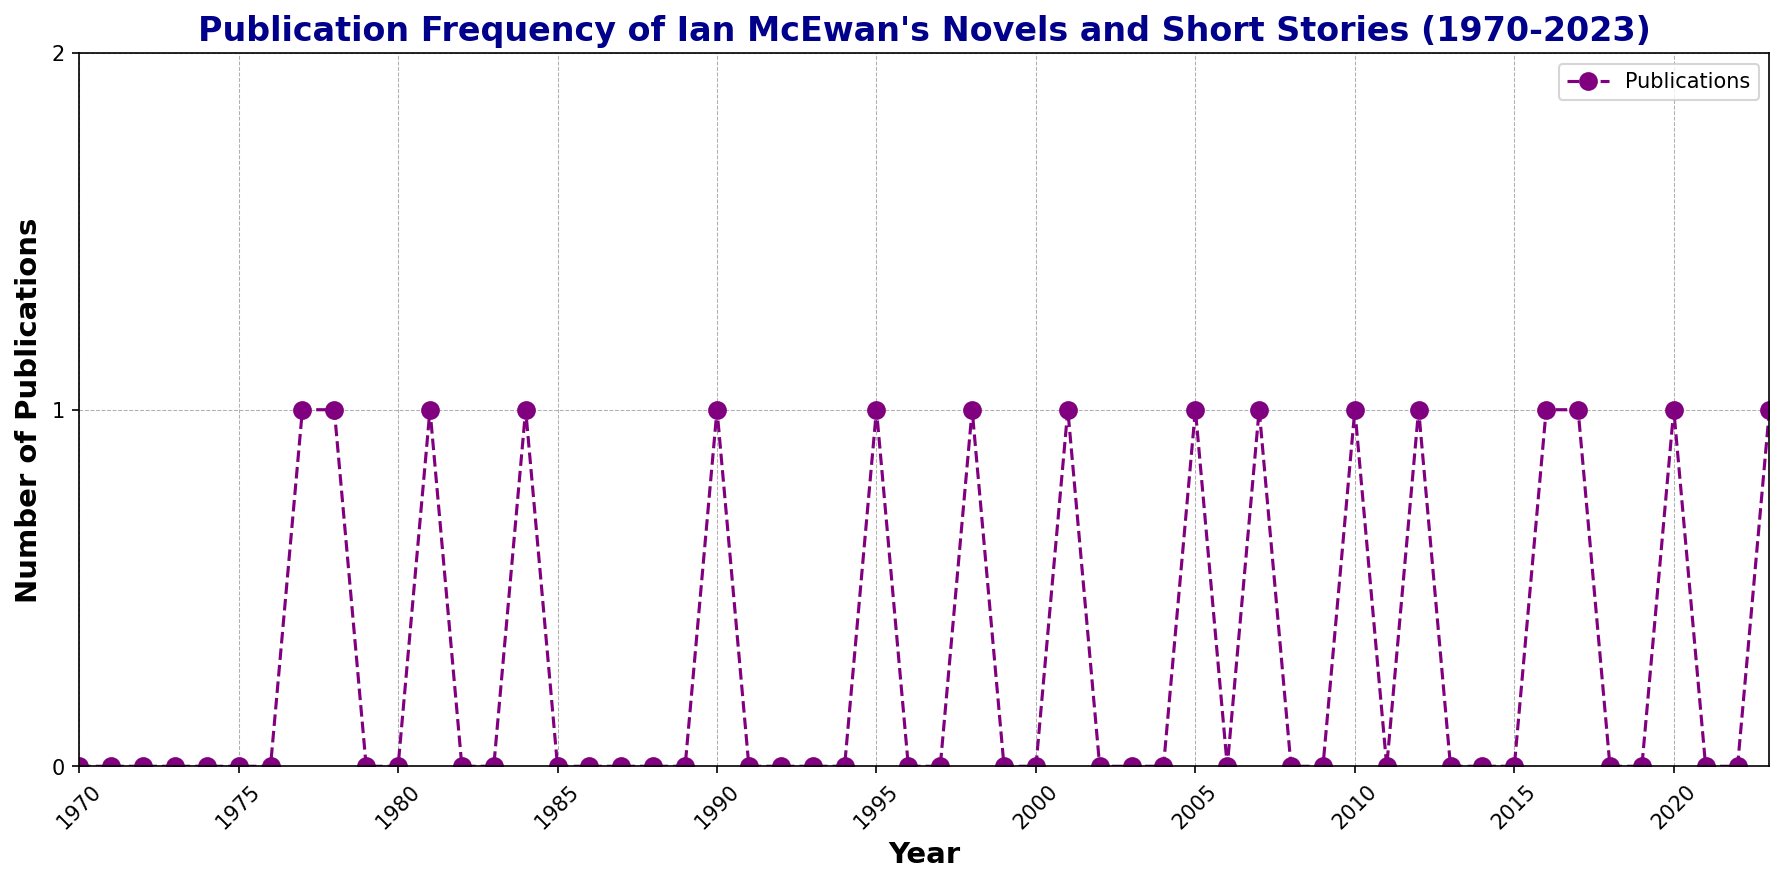What is the total number of publications from 1977 to 1984? Sum the number of publications from each year within this time range: 1 (1977) + 1 (1978) + 1 (1981) + 1 (1984). Adding these together: 1 + 1 + 1 + 1 = 4.
Answer: 4 Which year(s) had the most publications, and how many were there? By examining the figure, the peak of the line corresponds to the highest number of publications. In the chart, each peak marking signifies one publication, and surprisingly, no year has more than one publication. Therefore, multiple years share the highest count of 1 publication each, including 1977, 1978, 1981, 1984, 1990, 1995, 1998, 2001, 2005, 2007, 2010, 2012, 2016, 2017, 2020, and 2023.
Answer: 1977, 1978, 1981, 1984, 1990, 1995, 1998, 2001, 2005, 2007, 2010, 2012, 2016, 2017, 2020, 2023, 1 What is the average number of publications per year from 2000 to 2010? Sum the publications from 2000 to 2010 and then divide by the number of years. (0 + 0 + 1 + 0 + 0 + 1 + 0 + 1 + 0 + 0 + 1) = 4 publications over 11 years, giving an average of 4/11.
Answer: 0.36 How many years had zero publications? Count the number of instances where the number of publications is zero. By going through the provided data or visually examining the plot, count the years with zero publications. This can be tallied as: 42 years.
Answer: 42 How does the number of publications in the 2000s compare with the 2010s? Sum the total number of publications for each decade and compare. For the 2000s: 0 (2000) + 1 (2001) + 0 (2002) + 0 (2003) + 0 (2004) + 1 (2005) + 0 (2006) + 1 (2007) + 0 (2008) + 0 (2009) = 3. For the 2010s: 1 (2010) + 0 (2011) + 1 (2012) + 0 (2013) + 0 (2014) + 0 (2015) + 1 (2016) + 1 (2017) + 0 (2018) + 0 (2019) = 4. Hence, 3 (2000s) compared to 4 (2010s).
Answer: 3 vs. 4 Is there any trend noticeable in the early years (1970 to 1980) of the chart? Looking at the trend from 1970 to 1980, only the last three years show any publications with 1 publication per each relevant year (1977, 1978, and 1981), whereas the others reported zero publications. This represents an initial burst in publication activity towards the end of the decade.
Answer: Increasing trend from 1977 to 1981 In which decade did Ian McEwan have the lowest number of publications? Sum the publications per decade: 1970s (2), 1980s (1), 1990s (3), 2000s (3), 2010s (4), 2020s (1 so far within 2020-2023). The 1980s, with only 1 publication, has the lowest count.
Answer: 1980s What is the overall trend of publications from 2000 to 2023? Examining the plot from 2000 to 2023, it's seen that there's a moderate number of publications throughout these years, with slight increases and decreases but showing persistence. There isn't a sharp increase or consistent pattern but a generally steady output interspersed with inactive years.
Answer: Steady output with minor fluctuations 